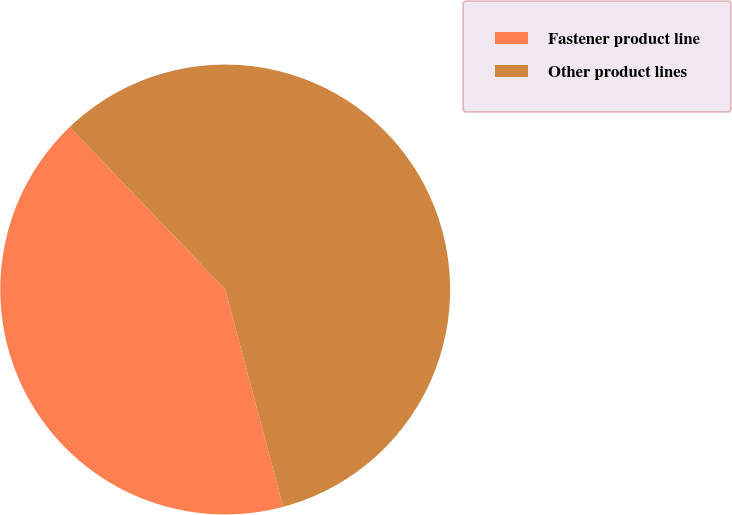Convert chart to OTSL. <chart><loc_0><loc_0><loc_500><loc_500><pie_chart><fcel>Fastener product line<fcel>Other product lines<nl><fcel>42.0%<fcel>58.0%<nl></chart> 